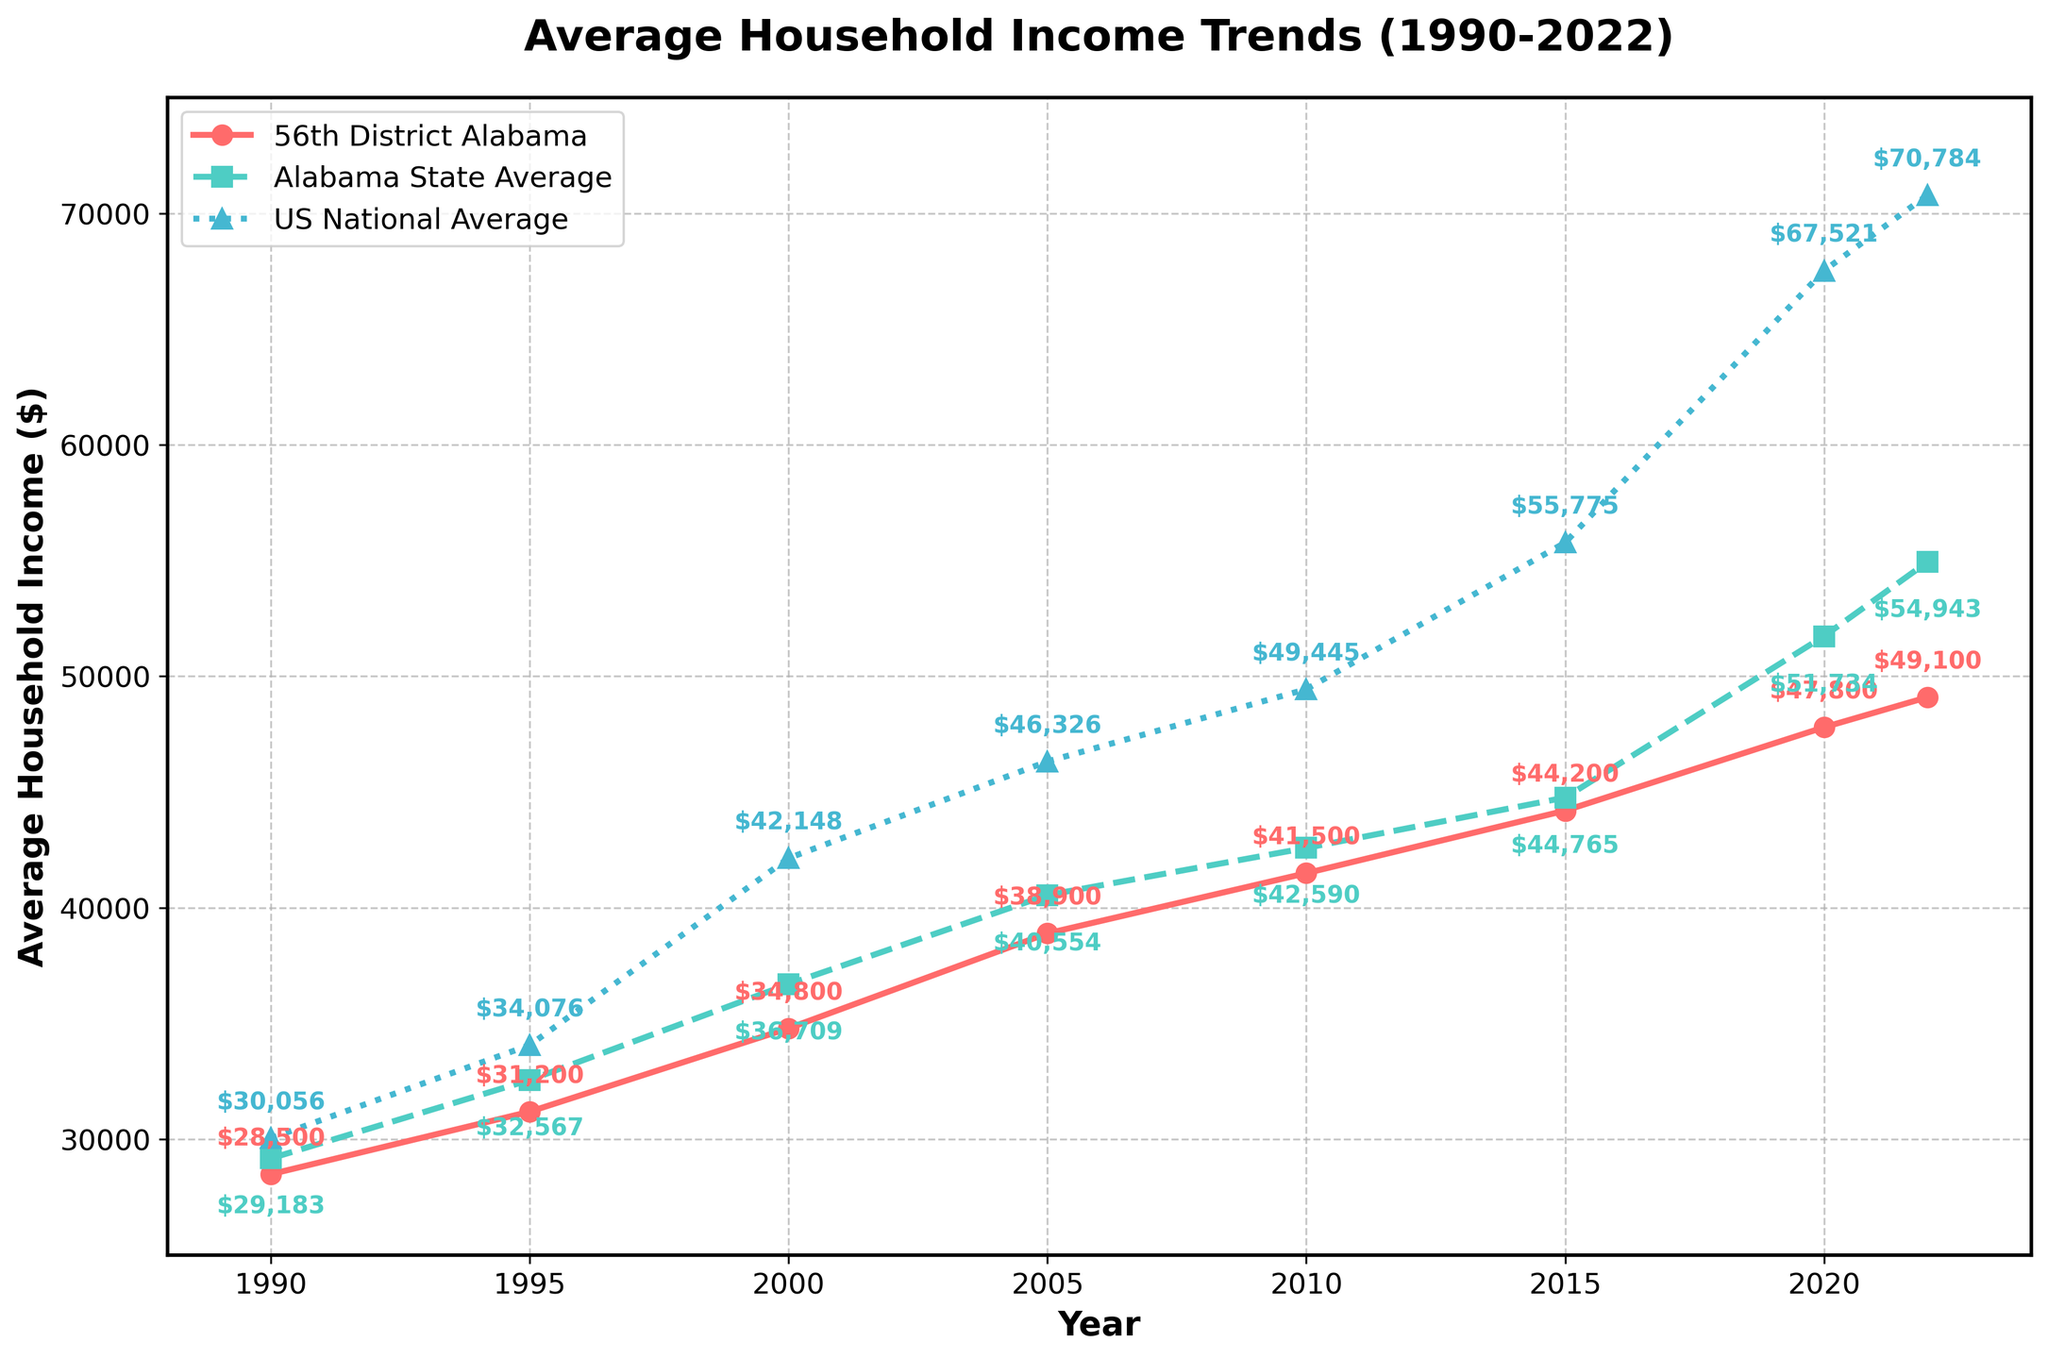What was the average household income in the 56th District of Alabama in 1990? Locate the red line on the graph, which represents the 56th District of Alabama. At the 1990 year mark, the labeled point indicates the average household income for that year.
Answer: $28,500 By how much did the average household income in the 56th District of Alabama increase from 1990 to 2022? Identify the income values for the 56th District of Alabama at the year marks 1990 and 2022 on the red line. Subtract the 1990 value from the 2022 value. $(49,100 - 28,500) = $20,600
Answer: $20,600 Which year did the average household income in Alabama state surpass $40,000? Check the green line on the graph representing Alabama state. Locate the point on the x-axis (years) where the income surpassed $40,000 by observing the annotation labels.
Answer: 2005 In 2000, was the average household income higher in the 56th District of Alabama, Alabama state, or the US national average? Compare the marked income points for the year 2000 across the red, green, and blue lines. The labels show $34,800 for the 56th District, $36,709 for Alabama, and $42,148 for the US national average.
Answer: US national average How much higher was the US national average household income compared to the 56th District of Alabama in 2020? Identify the 2020 income values from the blue line (US national average) and the red line (56th District of Alabama). Subtract the 56th District value from the US national average value. $(67,521 - 47,800) = $19,721
Answer: $19,721 Between which consecutive years did the 56th District of Alabama see the largest increase in household income? Calculate the difference in income between consecutive years for the red line and identify the maximum increase. $31200 - 28500 = 2700$, 34800 - 31200 = 3600$, 38900 - 34800 = 4100$, 41500 - 38900 = 2600$, 44200 - 41500 = 2700$, 47800 - 44200 = 3600$, 49100 - 47800 = 1300$. The largest difference, $4100, occurs between 2000 and 2005.
Answer: 2000-2005 How did the average household income in the 56th District of Alabama in 2022 compare to the Alabama state average that year? Locate the 2022 data points on the red and green lines. The 56th District is $49,100 while the Alabama state average is $54,943, indicating that the district's income is lower.
Answer: Lower What is the difference between the average household incomes in the 56th District of Alabama and the US national average in 2015? Find the 2015 income values on the red line for the 56th District and the blue line for the US national average. Compute the difference. $(55,775 - 44,200) = $11,575
Answer: $11,575 By how much did the average household income in the 56th District trail behind the US national average in 1990? Identify the income values for 1990 for both the 56th District (red line) and US national average (blue line). Subtract the district's value from the national average. $(30,056 - 28,500) = $1,556
Answer: $1,556 